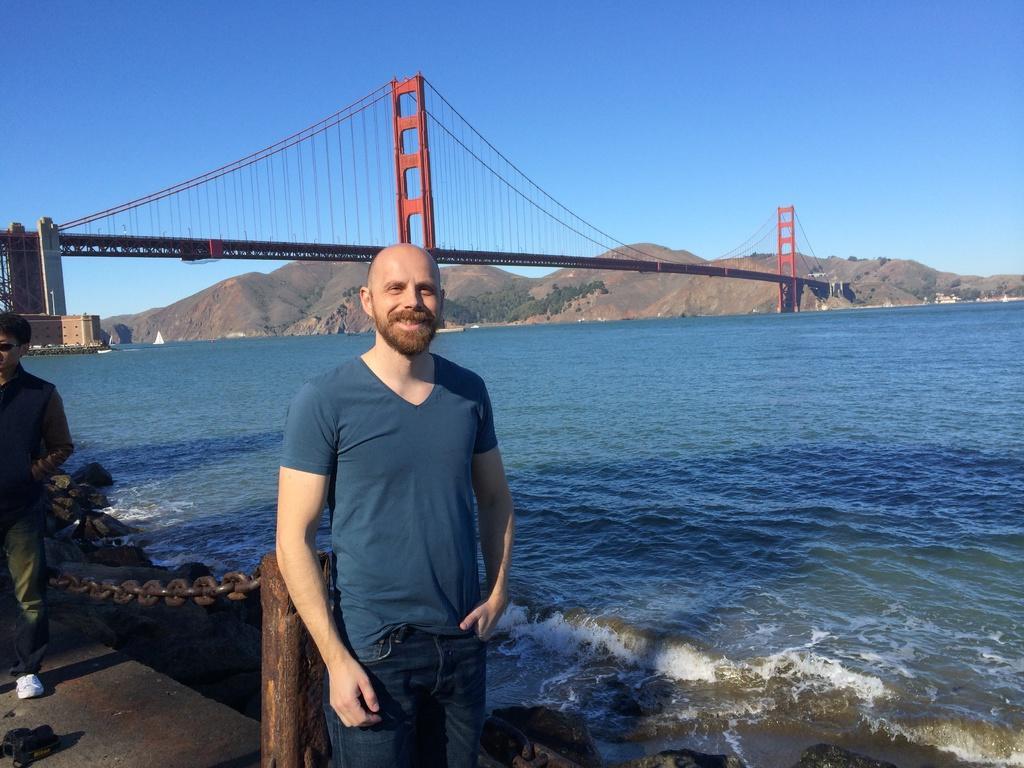In one or two sentences, can you explain what this image depicts? This is the man standing and smiling. This looks like a river with the water flowing. I can see a wooden pole with an iron chain. These are the rocks. Here is another person standing. This looks like a building. These are the hills. I can see the trees. This is the golden gate bridge. 